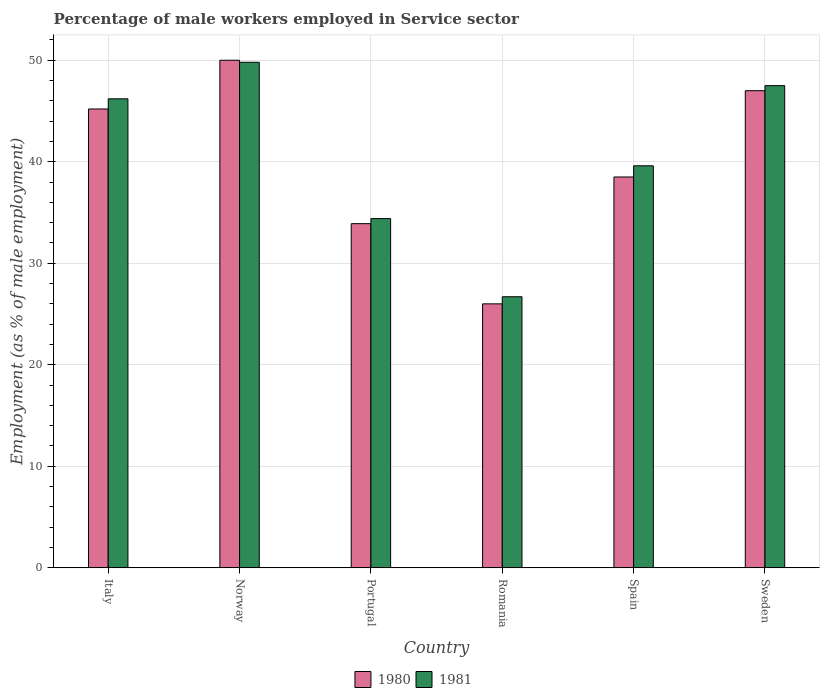How many different coloured bars are there?
Provide a succinct answer. 2. How many bars are there on the 3rd tick from the left?
Your answer should be very brief. 2. What is the label of the 5th group of bars from the left?
Make the answer very short. Spain. What is the percentage of male workers employed in Service sector in 1980 in Spain?
Your answer should be very brief. 38.5. Across all countries, what is the maximum percentage of male workers employed in Service sector in 1981?
Give a very brief answer. 49.8. Across all countries, what is the minimum percentage of male workers employed in Service sector in 1981?
Provide a succinct answer. 26.7. In which country was the percentage of male workers employed in Service sector in 1981 minimum?
Provide a succinct answer. Romania. What is the total percentage of male workers employed in Service sector in 1980 in the graph?
Offer a very short reply. 240.6. What is the difference between the percentage of male workers employed in Service sector in 1981 in Romania and that in Sweden?
Ensure brevity in your answer.  -20.8. What is the difference between the percentage of male workers employed in Service sector in 1980 in Romania and the percentage of male workers employed in Service sector in 1981 in Spain?
Make the answer very short. -13.6. What is the average percentage of male workers employed in Service sector in 1980 per country?
Ensure brevity in your answer.  40.1. What is the difference between the percentage of male workers employed in Service sector of/in 1980 and percentage of male workers employed in Service sector of/in 1981 in Spain?
Provide a succinct answer. -1.1. What is the ratio of the percentage of male workers employed in Service sector in 1980 in Portugal to that in Spain?
Provide a short and direct response. 0.88. What is the difference between the highest and the second highest percentage of male workers employed in Service sector in 1980?
Your answer should be compact. 4.8. What is the difference between the highest and the lowest percentage of male workers employed in Service sector in 1980?
Provide a short and direct response. 24. What does the 2nd bar from the right in Sweden represents?
Provide a short and direct response. 1980. How many bars are there?
Provide a short and direct response. 12. How many countries are there in the graph?
Offer a terse response. 6. Does the graph contain grids?
Ensure brevity in your answer.  Yes. How many legend labels are there?
Offer a very short reply. 2. How are the legend labels stacked?
Offer a very short reply. Horizontal. What is the title of the graph?
Offer a terse response. Percentage of male workers employed in Service sector. What is the label or title of the X-axis?
Give a very brief answer. Country. What is the label or title of the Y-axis?
Offer a terse response. Employment (as % of male employment). What is the Employment (as % of male employment) of 1980 in Italy?
Give a very brief answer. 45.2. What is the Employment (as % of male employment) in 1981 in Italy?
Make the answer very short. 46.2. What is the Employment (as % of male employment) in 1981 in Norway?
Offer a terse response. 49.8. What is the Employment (as % of male employment) of 1980 in Portugal?
Ensure brevity in your answer.  33.9. What is the Employment (as % of male employment) of 1981 in Portugal?
Provide a short and direct response. 34.4. What is the Employment (as % of male employment) in 1980 in Romania?
Ensure brevity in your answer.  26. What is the Employment (as % of male employment) in 1981 in Romania?
Keep it short and to the point. 26.7. What is the Employment (as % of male employment) of 1980 in Spain?
Make the answer very short. 38.5. What is the Employment (as % of male employment) of 1981 in Spain?
Your response must be concise. 39.6. What is the Employment (as % of male employment) of 1980 in Sweden?
Your answer should be compact. 47. What is the Employment (as % of male employment) of 1981 in Sweden?
Make the answer very short. 47.5. Across all countries, what is the maximum Employment (as % of male employment) of 1980?
Your answer should be compact. 50. Across all countries, what is the maximum Employment (as % of male employment) in 1981?
Your answer should be compact. 49.8. Across all countries, what is the minimum Employment (as % of male employment) of 1981?
Provide a succinct answer. 26.7. What is the total Employment (as % of male employment) in 1980 in the graph?
Ensure brevity in your answer.  240.6. What is the total Employment (as % of male employment) in 1981 in the graph?
Provide a short and direct response. 244.2. What is the difference between the Employment (as % of male employment) of 1980 in Italy and that in Norway?
Provide a short and direct response. -4.8. What is the difference between the Employment (as % of male employment) in 1981 in Italy and that in Norway?
Your answer should be compact. -3.6. What is the difference between the Employment (as % of male employment) of 1980 in Italy and that in Portugal?
Your answer should be compact. 11.3. What is the difference between the Employment (as % of male employment) of 1980 in Italy and that in Romania?
Your response must be concise. 19.2. What is the difference between the Employment (as % of male employment) in 1981 in Italy and that in Romania?
Offer a very short reply. 19.5. What is the difference between the Employment (as % of male employment) in 1981 in Italy and that in Spain?
Your response must be concise. 6.6. What is the difference between the Employment (as % of male employment) in 1980 in Italy and that in Sweden?
Keep it short and to the point. -1.8. What is the difference between the Employment (as % of male employment) of 1981 in Italy and that in Sweden?
Offer a very short reply. -1.3. What is the difference between the Employment (as % of male employment) of 1981 in Norway and that in Portugal?
Your response must be concise. 15.4. What is the difference between the Employment (as % of male employment) in 1980 in Norway and that in Romania?
Provide a succinct answer. 24. What is the difference between the Employment (as % of male employment) of 1981 in Norway and that in Romania?
Ensure brevity in your answer.  23.1. What is the difference between the Employment (as % of male employment) of 1981 in Norway and that in Spain?
Provide a succinct answer. 10.2. What is the difference between the Employment (as % of male employment) of 1980 in Norway and that in Sweden?
Offer a terse response. 3. What is the difference between the Employment (as % of male employment) in 1980 in Portugal and that in Romania?
Offer a terse response. 7.9. What is the difference between the Employment (as % of male employment) of 1980 in Portugal and that in Spain?
Your response must be concise. -4.6. What is the difference between the Employment (as % of male employment) in 1980 in Portugal and that in Sweden?
Make the answer very short. -13.1. What is the difference between the Employment (as % of male employment) in 1981 in Portugal and that in Sweden?
Your response must be concise. -13.1. What is the difference between the Employment (as % of male employment) of 1980 in Romania and that in Spain?
Offer a very short reply. -12.5. What is the difference between the Employment (as % of male employment) in 1981 in Romania and that in Spain?
Offer a terse response. -12.9. What is the difference between the Employment (as % of male employment) of 1981 in Romania and that in Sweden?
Keep it short and to the point. -20.8. What is the difference between the Employment (as % of male employment) of 1981 in Spain and that in Sweden?
Provide a succinct answer. -7.9. What is the difference between the Employment (as % of male employment) in 1980 in Italy and the Employment (as % of male employment) in 1981 in Norway?
Provide a short and direct response. -4.6. What is the difference between the Employment (as % of male employment) of 1980 in Italy and the Employment (as % of male employment) of 1981 in Romania?
Keep it short and to the point. 18.5. What is the difference between the Employment (as % of male employment) in 1980 in Norway and the Employment (as % of male employment) in 1981 in Romania?
Your response must be concise. 23.3. What is the difference between the Employment (as % of male employment) of 1980 in Norway and the Employment (as % of male employment) of 1981 in Spain?
Provide a succinct answer. 10.4. What is the difference between the Employment (as % of male employment) of 1980 in Norway and the Employment (as % of male employment) of 1981 in Sweden?
Give a very brief answer. 2.5. What is the difference between the Employment (as % of male employment) of 1980 in Portugal and the Employment (as % of male employment) of 1981 in Sweden?
Your answer should be very brief. -13.6. What is the difference between the Employment (as % of male employment) in 1980 in Romania and the Employment (as % of male employment) in 1981 in Spain?
Your response must be concise. -13.6. What is the difference between the Employment (as % of male employment) in 1980 in Romania and the Employment (as % of male employment) in 1981 in Sweden?
Your response must be concise. -21.5. What is the difference between the Employment (as % of male employment) of 1980 in Spain and the Employment (as % of male employment) of 1981 in Sweden?
Keep it short and to the point. -9. What is the average Employment (as % of male employment) of 1980 per country?
Provide a short and direct response. 40.1. What is the average Employment (as % of male employment) of 1981 per country?
Make the answer very short. 40.7. What is the difference between the Employment (as % of male employment) in 1980 and Employment (as % of male employment) in 1981 in Portugal?
Offer a very short reply. -0.5. What is the difference between the Employment (as % of male employment) in 1980 and Employment (as % of male employment) in 1981 in Romania?
Provide a succinct answer. -0.7. What is the difference between the Employment (as % of male employment) in 1980 and Employment (as % of male employment) in 1981 in Spain?
Your answer should be compact. -1.1. What is the ratio of the Employment (as % of male employment) of 1980 in Italy to that in Norway?
Give a very brief answer. 0.9. What is the ratio of the Employment (as % of male employment) in 1981 in Italy to that in Norway?
Make the answer very short. 0.93. What is the ratio of the Employment (as % of male employment) of 1981 in Italy to that in Portugal?
Ensure brevity in your answer.  1.34. What is the ratio of the Employment (as % of male employment) in 1980 in Italy to that in Romania?
Keep it short and to the point. 1.74. What is the ratio of the Employment (as % of male employment) in 1981 in Italy to that in Romania?
Provide a succinct answer. 1.73. What is the ratio of the Employment (as % of male employment) of 1980 in Italy to that in Spain?
Your answer should be very brief. 1.17. What is the ratio of the Employment (as % of male employment) in 1980 in Italy to that in Sweden?
Provide a succinct answer. 0.96. What is the ratio of the Employment (as % of male employment) in 1981 in Italy to that in Sweden?
Provide a succinct answer. 0.97. What is the ratio of the Employment (as % of male employment) of 1980 in Norway to that in Portugal?
Your answer should be very brief. 1.47. What is the ratio of the Employment (as % of male employment) of 1981 in Norway to that in Portugal?
Make the answer very short. 1.45. What is the ratio of the Employment (as % of male employment) in 1980 in Norway to that in Romania?
Ensure brevity in your answer.  1.92. What is the ratio of the Employment (as % of male employment) of 1981 in Norway to that in Romania?
Offer a terse response. 1.87. What is the ratio of the Employment (as % of male employment) in 1980 in Norway to that in Spain?
Your answer should be compact. 1.3. What is the ratio of the Employment (as % of male employment) of 1981 in Norway to that in Spain?
Make the answer very short. 1.26. What is the ratio of the Employment (as % of male employment) of 1980 in Norway to that in Sweden?
Provide a short and direct response. 1.06. What is the ratio of the Employment (as % of male employment) in 1981 in Norway to that in Sweden?
Make the answer very short. 1.05. What is the ratio of the Employment (as % of male employment) of 1980 in Portugal to that in Romania?
Ensure brevity in your answer.  1.3. What is the ratio of the Employment (as % of male employment) of 1981 in Portugal to that in Romania?
Offer a very short reply. 1.29. What is the ratio of the Employment (as % of male employment) of 1980 in Portugal to that in Spain?
Make the answer very short. 0.88. What is the ratio of the Employment (as % of male employment) of 1981 in Portugal to that in Spain?
Offer a terse response. 0.87. What is the ratio of the Employment (as % of male employment) in 1980 in Portugal to that in Sweden?
Provide a succinct answer. 0.72. What is the ratio of the Employment (as % of male employment) in 1981 in Portugal to that in Sweden?
Ensure brevity in your answer.  0.72. What is the ratio of the Employment (as % of male employment) in 1980 in Romania to that in Spain?
Give a very brief answer. 0.68. What is the ratio of the Employment (as % of male employment) of 1981 in Romania to that in Spain?
Your answer should be very brief. 0.67. What is the ratio of the Employment (as % of male employment) in 1980 in Romania to that in Sweden?
Provide a short and direct response. 0.55. What is the ratio of the Employment (as % of male employment) of 1981 in Romania to that in Sweden?
Provide a succinct answer. 0.56. What is the ratio of the Employment (as % of male employment) in 1980 in Spain to that in Sweden?
Provide a short and direct response. 0.82. What is the ratio of the Employment (as % of male employment) in 1981 in Spain to that in Sweden?
Offer a terse response. 0.83. What is the difference between the highest and the second highest Employment (as % of male employment) of 1980?
Your answer should be very brief. 3. What is the difference between the highest and the second highest Employment (as % of male employment) in 1981?
Make the answer very short. 2.3. What is the difference between the highest and the lowest Employment (as % of male employment) in 1980?
Provide a succinct answer. 24. What is the difference between the highest and the lowest Employment (as % of male employment) of 1981?
Ensure brevity in your answer.  23.1. 